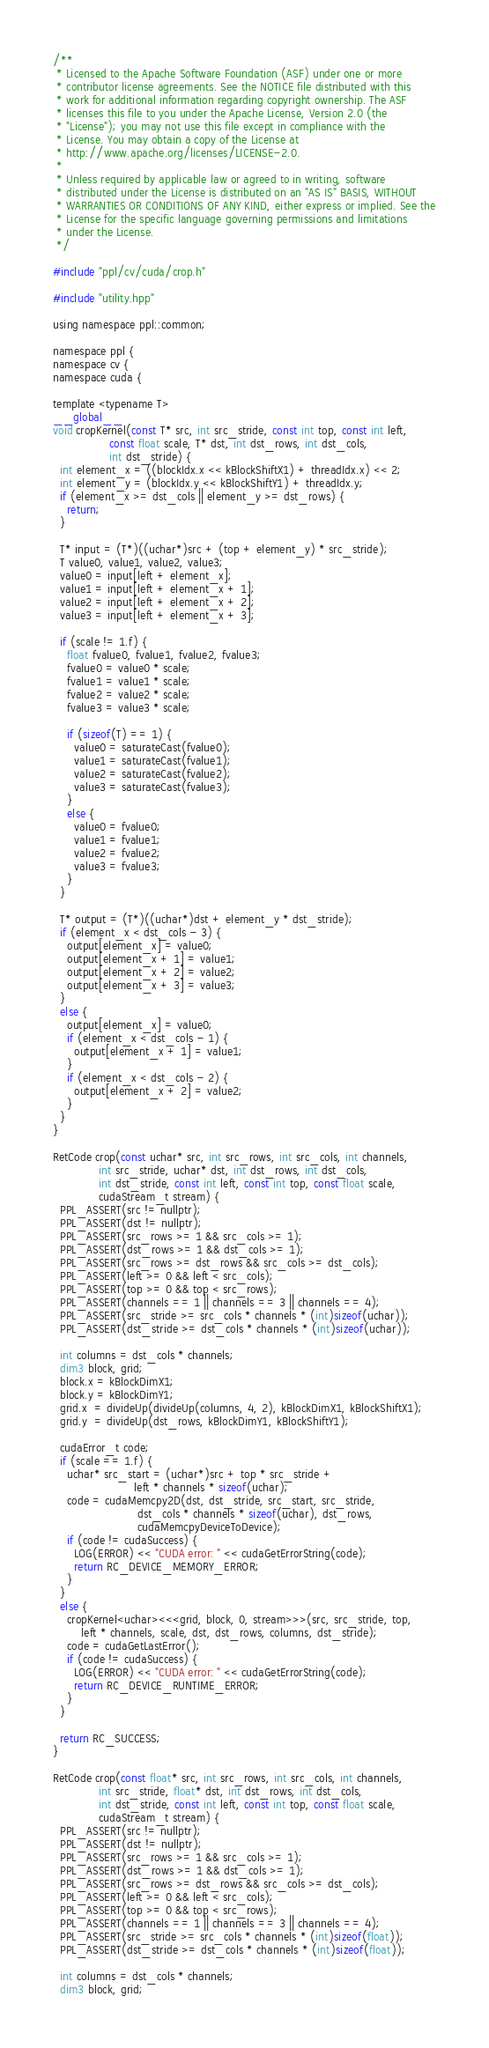<code> <loc_0><loc_0><loc_500><loc_500><_Cuda_>/**
 * Licensed to the Apache Software Foundation (ASF) under one or more
 * contributor license agreements. See the NOTICE file distributed with this
 * work for additional information regarding copyright ownership. The ASF
 * licenses this file to you under the Apache License, Version 2.0 (the
 * "License"); you may not use this file except in compliance with the
 * License. You may obtain a copy of the License at
 * http://www.apache.org/licenses/LICENSE-2.0.
 *
 * Unless required by applicable law or agreed to in writing, software
 * distributed under the License is distributed on an "AS IS" BASIS, WITHOUT
 * WARRANTIES OR CONDITIONS OF ANY KIND, either express or implied. See the
 * License for the specific language governing permissions and limitations
 * under the License.
 */

#include "ppl/cv/cuda/crop.h"

#include "utility.hpp"

using namespace ppl::common;

namespace ppl {
namespace cv {
namespace cuda {

template <typename T>
__global__
void cropKernel(const T* src, int src_stride, const int top, const int left,
                const float scale, T* dst, int dst_rows, int dst_cols,
                int dst_stride) {
  int element_x = ((blockIdx.x << kBlockShiftX1) + threadIdx.x) << 2;
  int element_y = (blockIdx.y << kBlockShiftY1) + threadIdx.y;
  if (element_x >= dst_cols || element_y >= dst_rows) {
    return;
  }

  T* input = (T*)((uchar*)src + (top + element_y) * src_stride);
  T value0, value1, value2, value3;
  value0 = input[left + element_x];
  value1 = input[left + element_x + 1];
  value2 = input[left + element_x + 2];
  value3 = input[left + element_x + 3];

  if (scale != 1.f) {
    float fvalue0, fvalue1, fvalue2, fvalue3;
    fvalue0 = value0 * scale;
    fvalue1 = value1 * scale;
    fvalue2 = value2 * scale;
    fvalue3 = value3 * scale;

    if (sizeof(T) == 1) {
      value0 = saturateCast(fvalue0);
      value1 = saturateCast(fvalue1);
      value2 = saturateCast(fvalue2);
      value3 = saturateCast(fvalue3);
    }
    else {
      value0 = fvalue0;
      value1 = fvalue1;
      value2 = fvalue2;
      value3 = fvalue3;
    }
  }

  T* output = (T*)((uchar*)dst + element_y * dst_stride);
  if (element_x < dst_cols - 3) {
    output[element_x] = value0;
    output[element_x + 1] = value1;
    output[element_x + 2] = value2;
    output[element_x + 3] = value3;
  }
  else {
    output[element_x] = value0;
    if (element_x < dst_cols - 1) {
      output[element_x + 1] = value1;
    }
    if (element_x < dst_cols - 2) {
      output[element_x + 2] = value2;
    }
  }
}

RetCode crop(const uchar* src, int src_rows, int src_cols, int channels,
             int src_stride, uchar* dst, int dst_rows, int dst_cols,
             int dst_stride, const int left, const int top, const float scale,
             cudaStream_t stream) {
  PPL_ASSERT(src != nullptr);
  PPL_ASSERT(dst != nullptr);
  PPL_ASSERT(src_rows >= 1 && src_cols >= 1);
  PPL_ASSERT(dst_rows >= 1 && dst_cols >= 1);
  PPL_ASSERT(src_rows >= dst_rows && src_cols >= dst_cols);
  PPL_ASSERT(left >= 0 && left < src_cols);
  PPL_ASSERT(top >= 0 && top < src_rows);
  PPL_ASSERT(channels == 1 || channels == 3 || channels == 4);
  PPL_ASSERT(src_stride >= src_cols * channels * (int)sizeof(uchar));
  PPL_ASSERT(dst_stride >= dst_cols * channels * (int)sizeof(uchar));

  int columns = dst_cols * channels;
  dim3 block, grid;
  block.x = kBlockDimX1;
  block.y = kBlockDimY1;
  grid.x  = divideUp(divideUp(columns, 4, 2), kBlockDimX1, kBlockShiftX1);
  grid.y  = divideUp(dst_rows, kBlockDimY1, kBlockShiftY1);

  cudaError_t code;
  if (scale == 1.f) {
    uchar* src_start = (uchar*)src + top * src_stride +
                       left * channels * sizeof(uchar);
    code = cudaMemcpy2D(dst, dst_stride, src_start, src_stride,
                        dst_cols * channels * sizeof(uchar), dst_rows,
                        cudaMemcpyDeviceToDevice);
    if (code != cudaSuccess) {
      LOG(ERROR) << "CUDA error: " << cudaGetErrorString(code);
      return RC_DEVICE_MEMORY_ERROR;
    }
  }
  else {
    cropKernel<uchar><<<grid, block, 0, stream>>>(src, src_stride, top,
        left * channels, scale, dst, dst_rows, columns, dst_stride);
    code = cudaGetLastError();
    if (code != cudaSuccess) {
      LOG(ERROR) << "CUDA error: " << cudaGetErrorString(code);
      return RC_DEVICE_RUNTIME_ERROR;
    }
  }

  return RC_SUCCESS;
}

RetCode crop(const float* src, int src_rows, int src_cols, int channels,
             int src_stride, float* dst, int dst_rows, int dst_cols,
             int dst_stride, const int left, const int top, const float scale,
             cudaStream_t stream) {
  PPL_ASSERT(src != nullptr);
  PPL_ASSERT(dst != nullptr);
  PPL_ASSERT(src_rows >= 1 && src_cols >= 1);
  PPL_ASSERT(dst_rows >= 1 && dst_cols >= 1);
  PPL_ASSERT(src_rows >= dst_rows && src_cols >= dst_cols);
  PPL_ASSERT(left >= 0 && left < src_cols);
  PPL_ASSERT(top >= 0 && top < src_rows);
  PPL_ASSERT(channels == 1 || channels == 3 || channels == 4);
  PPL_ASSERT(src_stride >= src_cols * channels * (int)sizeof(float));
  PPL_ASSERT(dst_stride >= dst_cols * channels * (int)sizeof(float));

  int columns = dst_cols * channels;
  dim3 block, grid;</code> 